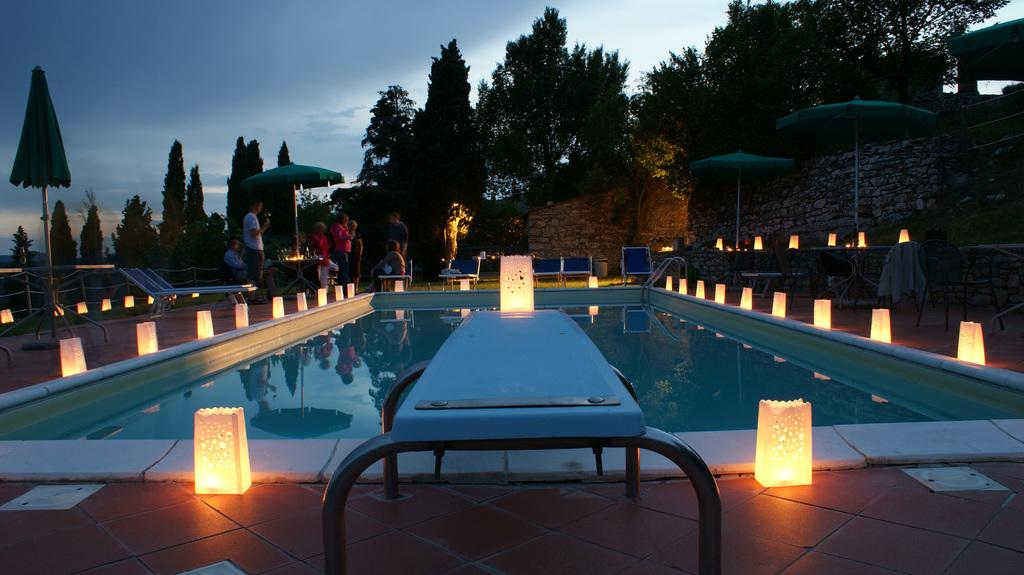What is the main feature of the image? There is a swimming pool in the image. How is the swimming pool decorated? The swimming pool is decorated with lights. Can you describe the background of the image? There are people and trees visible in the background of the image. What type of snake can be seen slithering near the swimming pool in the image? There is no snake present in the image; it only features a swimming pool, lights, people, and trees in the background. Can you tell me how many boots are visible in the image? There are no boots present in the image. 